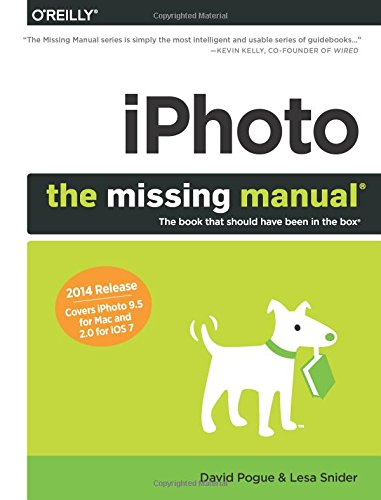What is the title of this book? The full title of this book is 'iPhoto: The Missing Manual: 2014 release, covers iPhoto 9.5 for Mac and 2.0 for iOS 7', which offers detailed information essential for handling the specified versions of the software. 